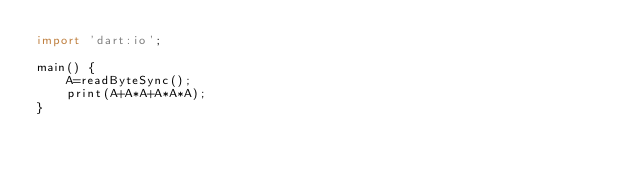<code> <loc_0><loc_0><loc_500><loc_500><_Dart_>import 'dart:io';

main() {
    A=readByteSync();
    print(A+A*A+A*A*A);
}</code> 